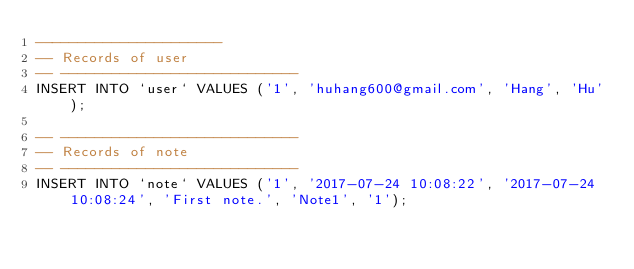<code> <loc_0><loc_0><loc_500><loc_500><_SQL_>----------------------
-- Records of user
-- ----------------------------
INSERT INTO `user` VALUES ('1', 'huhang600@gmail.com', 'Hang', 'Hu');

-- ----------------------------
-- Records of note
-- ----------------------------
INSERT INTO `note` VALUES ('1', '2017-07-24 10:08:22', '2017-07-24 10:08:24', 'First note.', 'Note1', '1');


</code> 